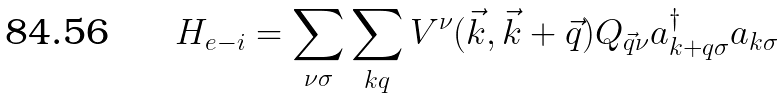<formula> <loc_0><loc_0><loc_500><loc_500>H _ { e - i } = \sum _ { \nu \sigma } \sum _ { k q } V ^ { \nu } ( \vec { k } , \vec { k } + \vec { q } ) Q _ { \vec { q } \nu } a ^ { \dagger } _ { k + q \sigma } a _ { k \sigma }</formula> 